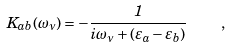Convert formula to latex. <formula><loc_0><loc_0><loc_500><loc_500>K _ { a b } ( \omega _ { \nu } ) = - \frac { 1 } { i \omega _ { \nu } + ( \varepsilon _ { a } - \varepsilon _ { b } ) } \quad ,</formula> 